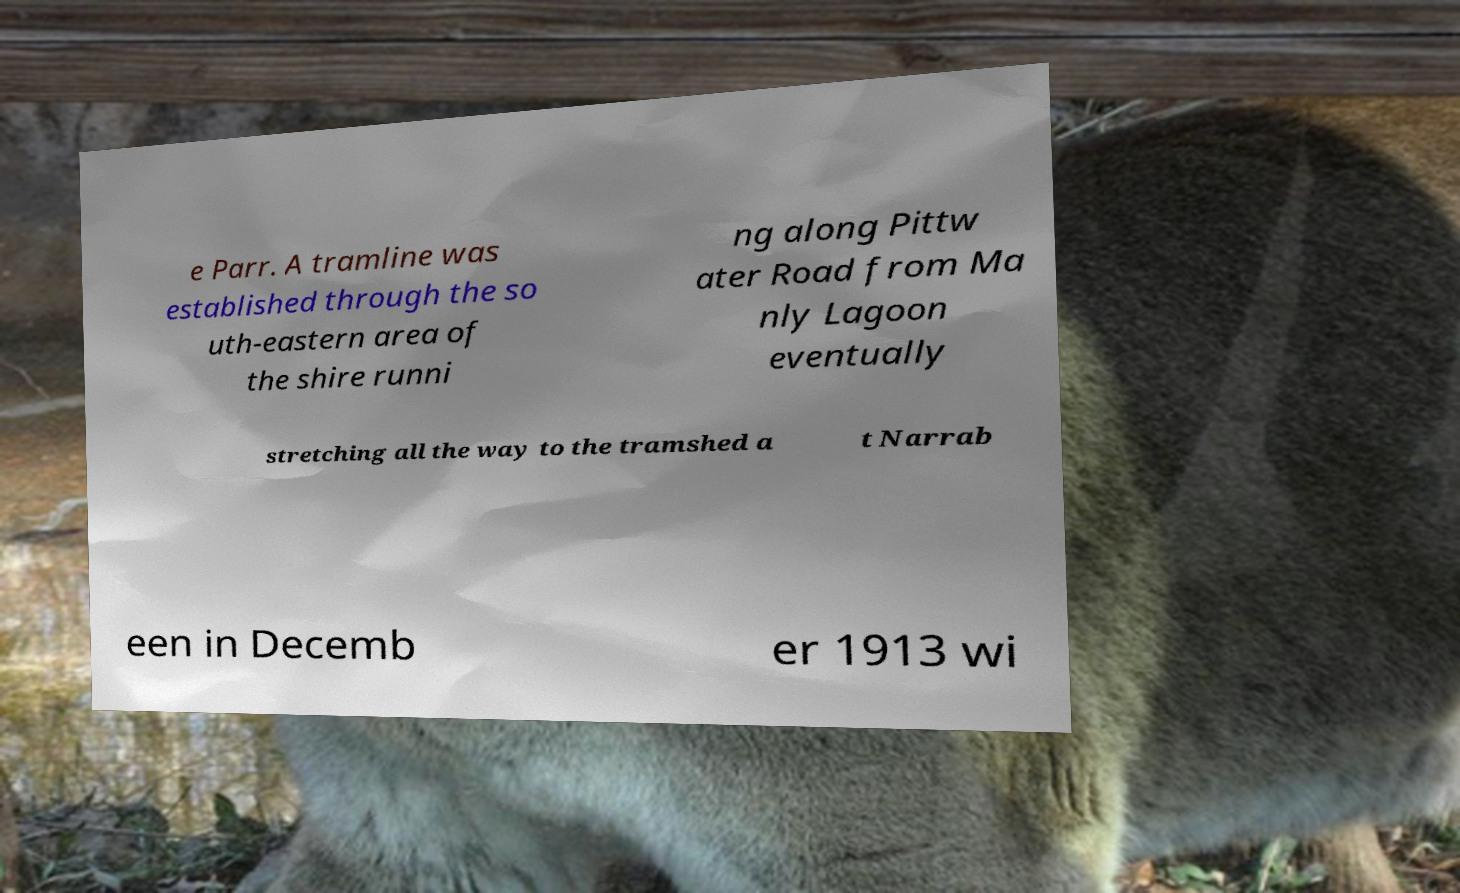What messages or text are displayed in this image? I need them in a readable, typed format. e Parr. A tramline was established through the so uth-eastern area of the shire runni ng along Pittw ater Road from Ma nly Lagoon eventually stretching all the way to the tramshed a t Narrab een in Decemb er 1913 wi 